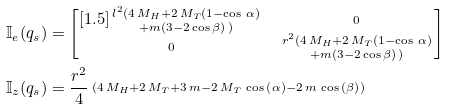Convert formula to latex. <formula><loc_0><loc_0><loc_500><loc_500>\mathbb { I } _ { e } ( q _ { s } ) & = \begin{bmatrix} [ 1 . 5 ] \begin{smallmatrix} l ^ { 2 } ( 4 \, { M _ { H } } + 2 \, { M _ { T } } ( 1 - \cos \, \alpha ) \\ + m ( 3 - 2 \cos \beta ) \, ) \end{smallmatrix} & \begin{smallmatrix} 0 \end{smallmatrix} \\ \begin{smallmatrix} 0 \end{smallmatrix} & \begin{smallmatrix} r ^ { 2 } ( 4 \, { M _ { H } } + 2 \, { M _ { T } } ( 1 - \cos \, \alpha ) \\ + m ( 3 - 2 \cos \beta ) \, ) \end{smallmatrix} \end{bmatrix} \\ \mathbb { I } _ { z } ( q _ { s } ) & = \frac { r ^ { 2 } } { 4 } \begin{smallmatrix} { \left ( 4 \, { M _ { H } } + 2 \, { M _ { T } } + 3 \, m - 2 \, { M _ { T } } \, \cos \, \left ( \alpha \right ) - 2 \, m \, \cos \, \left ( \beta \right ) \right ) } \end{smallmatrix}</formula> 